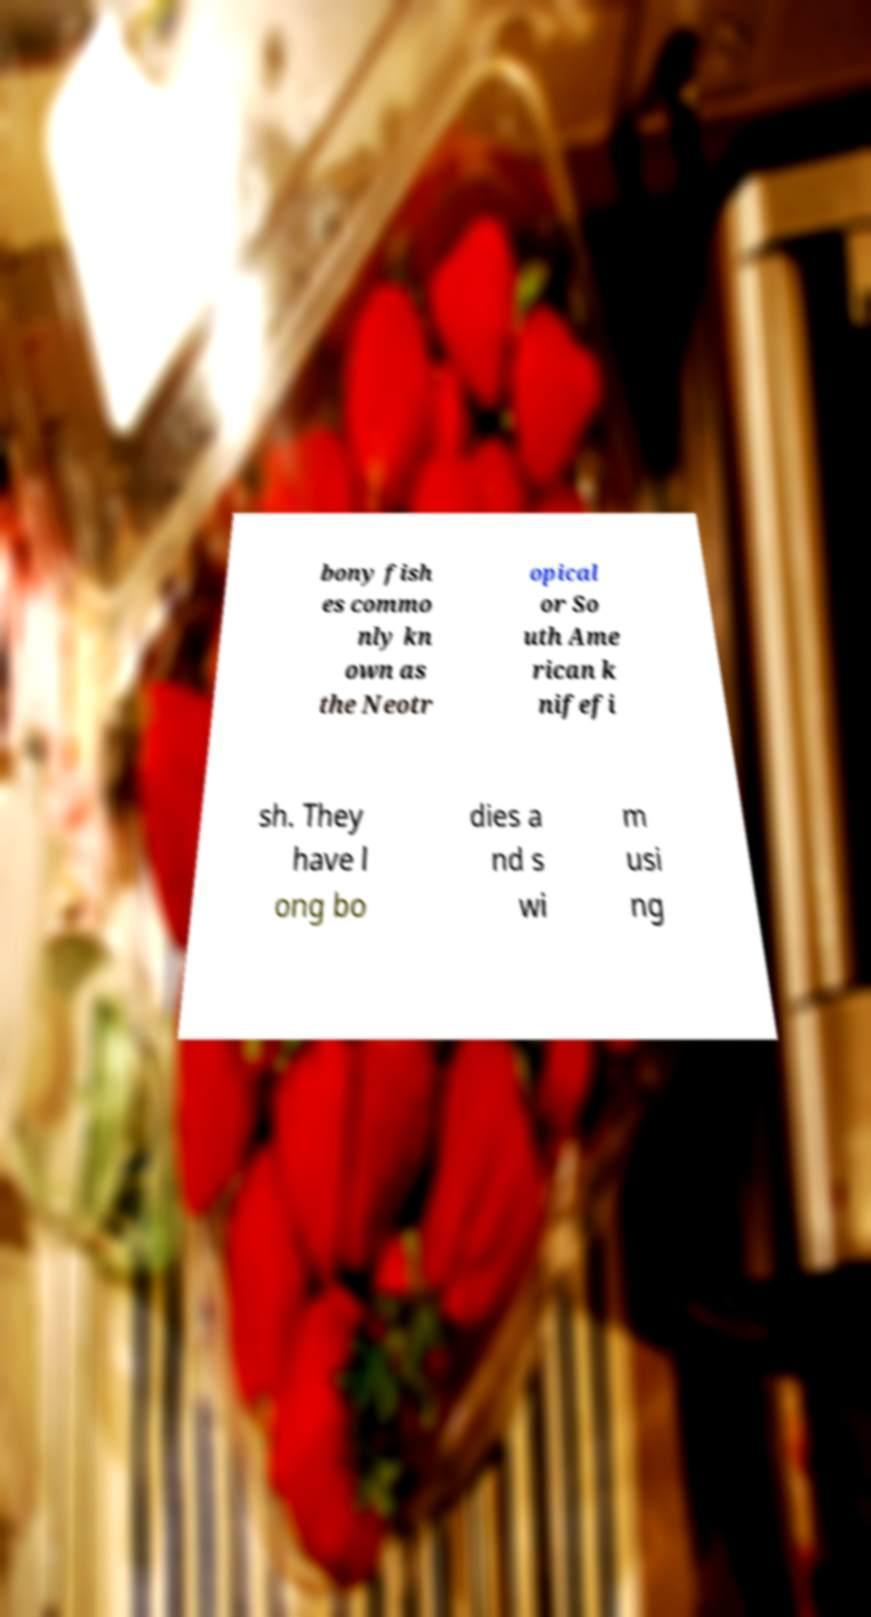Can you accurately transcribe the text from the provided image for me? bony fish es commo nly kn own as the Neotr opical or So uth Ame rican k nifefi sh. They have l ong bo dies a nd s wi m usi ng 